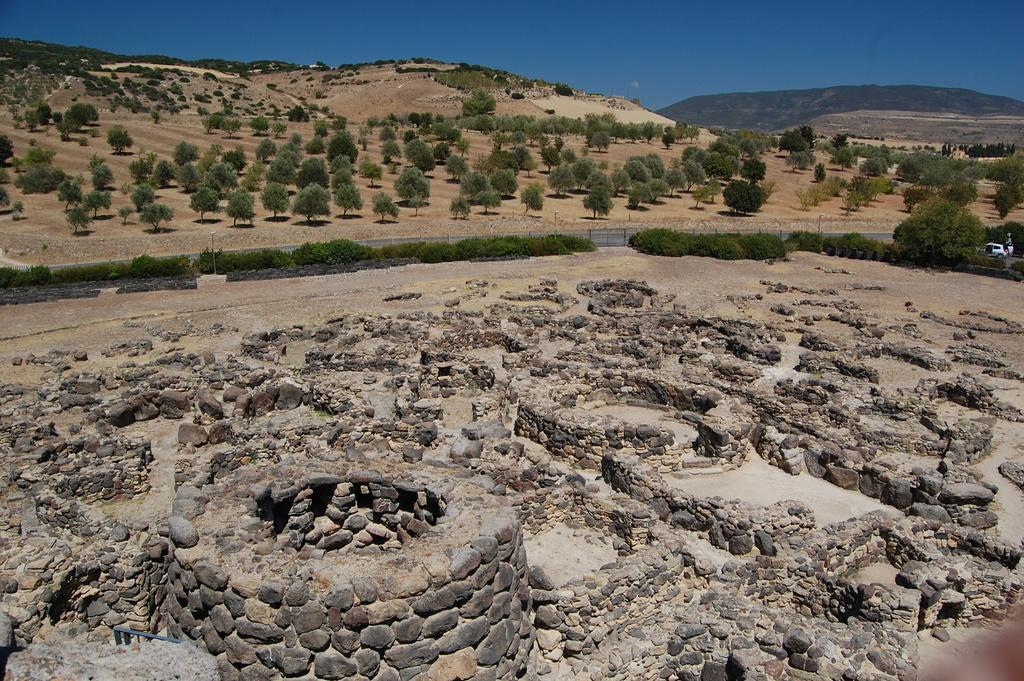What type of terrain is visible in the image? The land is covered with rocks and sand. Are there any plants or vegetation present in the image? Yes, there are plenty of trees around the land. What can be seen in the distance in the image? There is a mountain visible in the background. What type of milk is being produced by the cows in the image? There are no cows or milk present in the image; it features a landscape with rocks, sand, trees, and a mountain. Is there a veil covering any part of the landscape in the image? There is no veil present in the image; it is a natural landscape with rocks, sand, trees, and a mountain. 